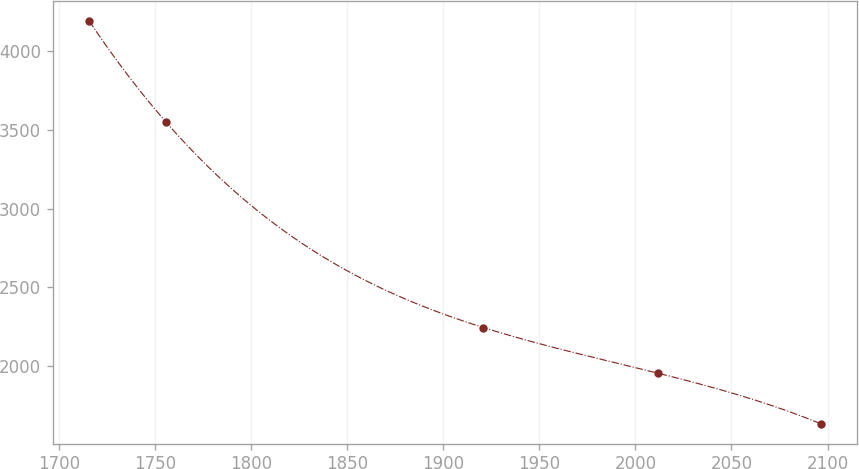Convert chart to OTSL. <chart><loc_0><loc_0><loc_500><loc_500><line_chart><ecel><fcel>Unnamed: 1<nl><fcel>1715.73<fcel>4191.46<nl><fcel>1755.59<fcel>3551.42<nl><fcel>1920.91<fcel>2245.36<nl><fcel>2012<fcel>1954.89<nl><fcel>2096.34<fcel>1635.67<nl></chart> 